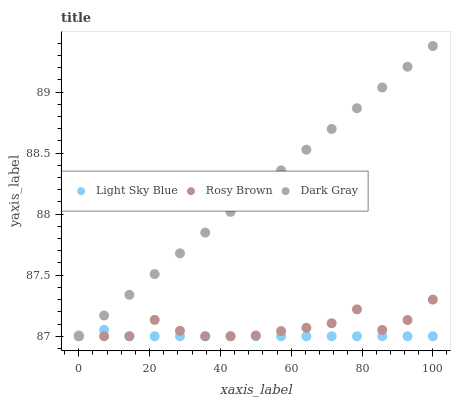Does Light Sky Blue have the minimum area under the curve?
Answer yes or no. Yes. Does Dark Gray have the maximum area under the curve?
Answer yes or no. Yes. Does Rosy Brown have the minimum area under the curve?
Answer yes or no. No. Does Rosy Brown have the maximum area under the curve?
Answer yes or no. No. Is Dark Gray the smoothest?
Answer yes or no. Yes. Is Rosy Brown the roughest?
Answer yes or no. Yes. Is Light Sky Blue the smoothest?
Answer yes or no. No. Is Light Sky Blue the roughest?
Answer yes or no. No. Does Dark Gray have the lowest value?
Answer yes or no. Yes. Does Dark Gray have the highest value?
Answer yes or no. Yes. Does Rosy Brown have the highest value?
Answer yes or no. No. Does Rosy Brown intersect Light Sky Blue?
Answer yes or no. Yes. Is Rosy Brown less than Light Sky Blue?
Answer yes or no. No. Is Rosy Brown greater than Light Sky Blue?
Answer yes or no. No. 